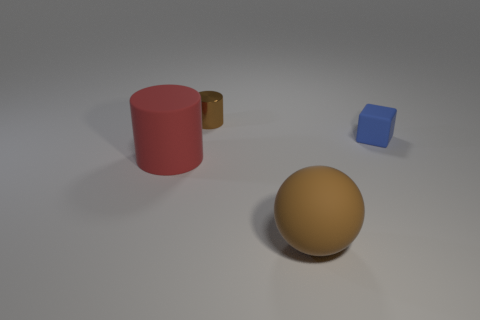Are there any other things that have the same material as the small cylinder?
Provide a short and direct response. No. Are there any metal objects of the same color as the ball?
Ensure brevity in your answer.  Yes. The tiny object to the left of the big matte object to the right of the brown thing behind the blue matte object is what shape?
Your answer should be compact. Cylinder. What material is the cylinder in front of the tiny blue thing?
Your answer should be very brief. Rubber. There is a cylinder that is behind the big object behind the brown object that is right of the small metal cylinder; what size is it?
Offer a very short reply. Small. Do the blue matte block and the cylinder that is in front of the block have the same size?
Ensure brevity in your answer.  No. The small object behind the small blue thing is what color?
Provide a succinct answer. Brown. What is the shape of the metallic thing that is the same color as the big rubber sphere?
Offer a terse response. Cylinder. There is a brown object that is behind the large red rubber object; what shape is it?
Your answer should be very brief. Cylinder. How many brown objects are either shiny things or big matte things?
Ensure brevity in your answer.  2. 